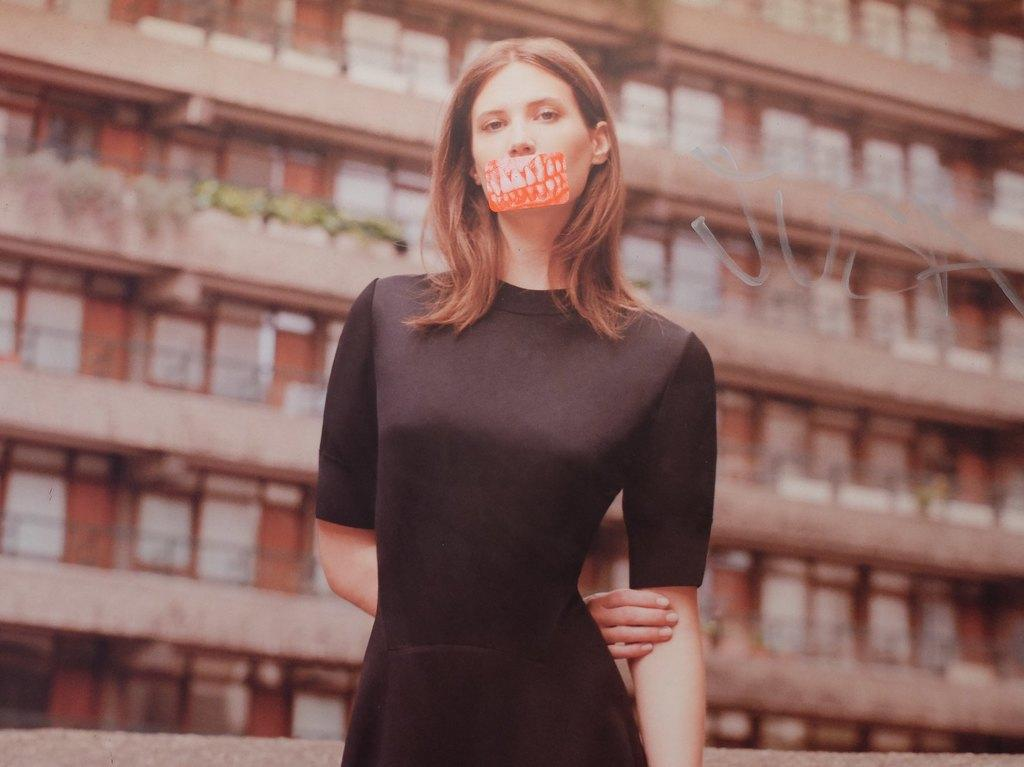Who is the main subject in the image? There is a woman in the image. What is the woman wearing? The woman is wearing a black dress. Is there anything unusual about the woman's appearance? Yes, there is a sticker on the woman's mouth. What can be seen in the background of the image? There is a building in the background of the image. What type of camera is the woman using to take pictures in the image? There is no camera visible in the image, and the woman is not taking pictures. 